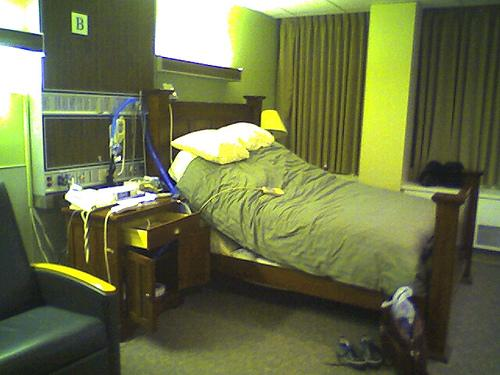Can you describe the hospital bed in the image using information from the image? The hospital bed has a wooden frame, sheets, a headboard, and a footboard, with a remote unit and a light above it. Using the image, describe the nightstand in the image. The large wooden nightstand has open cabinet doors, an open top drawer, and a door on it. Determine the purpose of the scene based on the objects and their interactions in the image. The scene appears to be in a hospital room, with a bed, medical monitoring equipment, and various objects for patient comfort and care. Analyze the interaction between the medical monitoring equipment and the blue breathing tube. The medical monitoring equipment and the blue breathing tube are adjacent and possibly connected, indicating their use together for patient care. What type of chair is in the image, according to the image? There is a black reclining chair and a blue leather easy chair in the image. Assess the quality of the image based on the number and clarity of objects described in the image. The image seems to have a high quality, as numerous objects are mentioned clearly and have detailed descriptions in the image. Identify the location of the letter B in the image and describe its appearance. The letter B is on the wall, in a white square label, possibly indicating a room number or a patient's name. Briefly describe the window area in the image using the provided image details. The window has green pleated curtains, long blinds, and a brown curtain pulled across it. Based on the image, what kind of footwear is present in the image? There are sneakers, black athletic shoes with blue shoelaces, and blue tie casual shoes in the image. Count how many pillows are mentioned in the image. There are 3 pillows mentioned in the image. Can you see the painting of a landscape on the wall above the bed? No, it's not mentioned in the image. Is the computer on the desk turned on? There is no mention of a computer on the desk. 